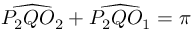<formula> <loc_0><loc_0><loc_500><loc_500>{ \widehat { P _ { 2 } Q O _ { 2 } } } + { \widehat { P _ { 2 } Q O _ { 1 } } } = \pi</formula> 